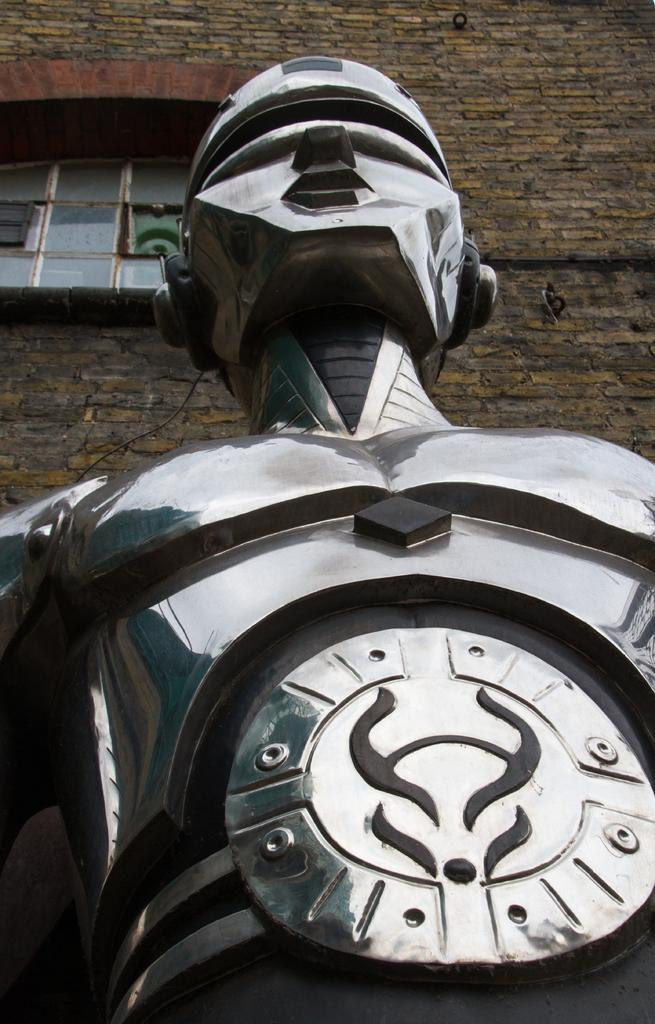What is the main subject in the image? There is a metal statue in the image. Where is the metal statue located in relation to the image? The metal statue is in the front of the image. What can be seen behind the metal statue in the image? There is a building behind the metal statue in the image. What type of ticket is required to enter the song in the image? There is no ticket or song present in the image; it features a metal statue and a building in the background. 